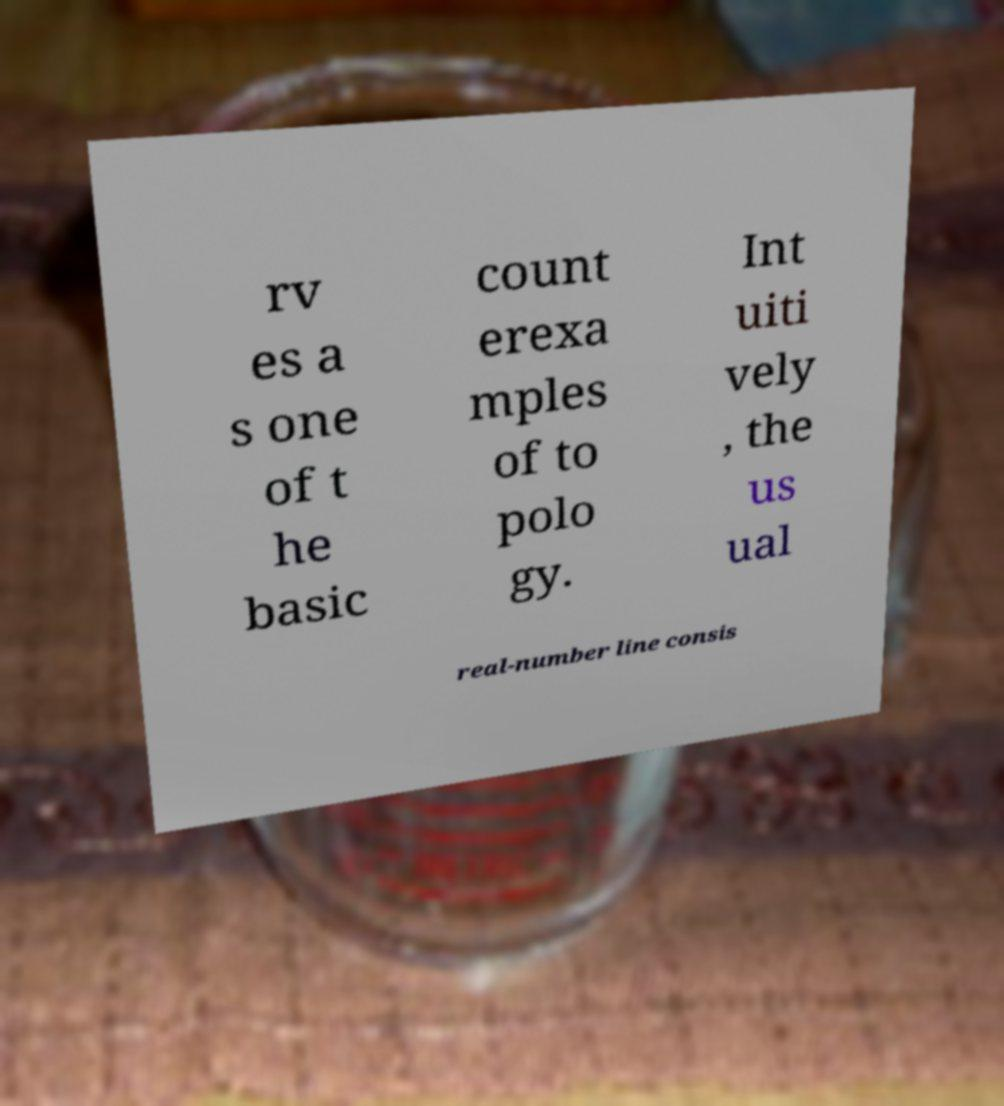Can you read and provide the text displayed in the image?This photo seems to have some interesting text. Can you extract and type it out for me? rv es a s one of t he basic count erexa mples of to polo gy. Int uiti vely , the us ual real-number line consis 